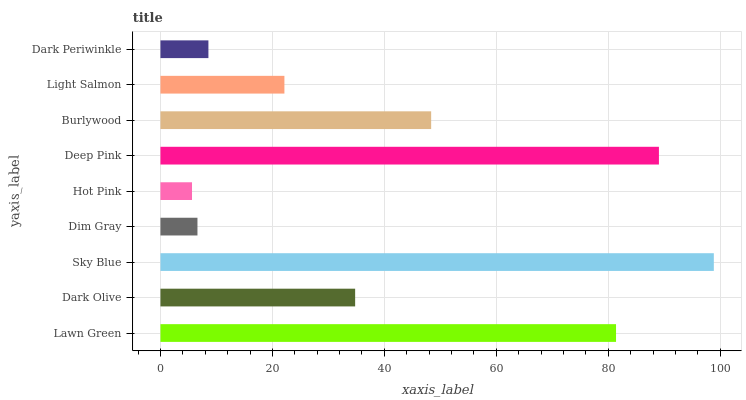Is Hot Pink the minimum?
Answer yes or no. Yes. Is Sky Blue the maximum?
Answer yes or no. Yes. Is Dark Olive the minimum?
Answer yes or no. No. Is Dark Olive the maximum?
Answer yes or no. No. Is Lawn Green greater than Dark Olive?
Answer yes or no. Yes. Is Dark Olive less than Lawn Green?
Answer yes or no. Yes. Is Dark Olive greater than Lawn Green?
Answer yes or no. No. Is Lawn Green less than Dark Olive?
Answer yes or no. No. Is Dark Olive the high median?
Answer yes or no. Yes. Is Dark Olive the low median?
Answer yes or no. Yes. Is Burlywood the high median?
Answer yes or no. No. Is Hot Pink the low median?
Answer yes or no. No. 